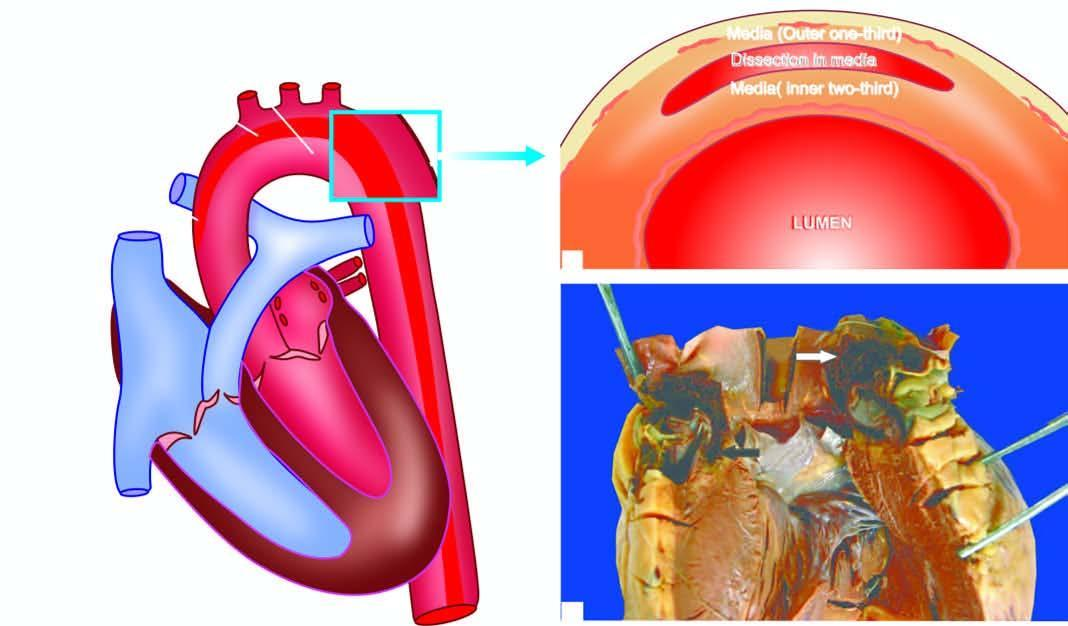what is seen with the heart?
Answer the question using a single word or phrase. The ascending aorta 